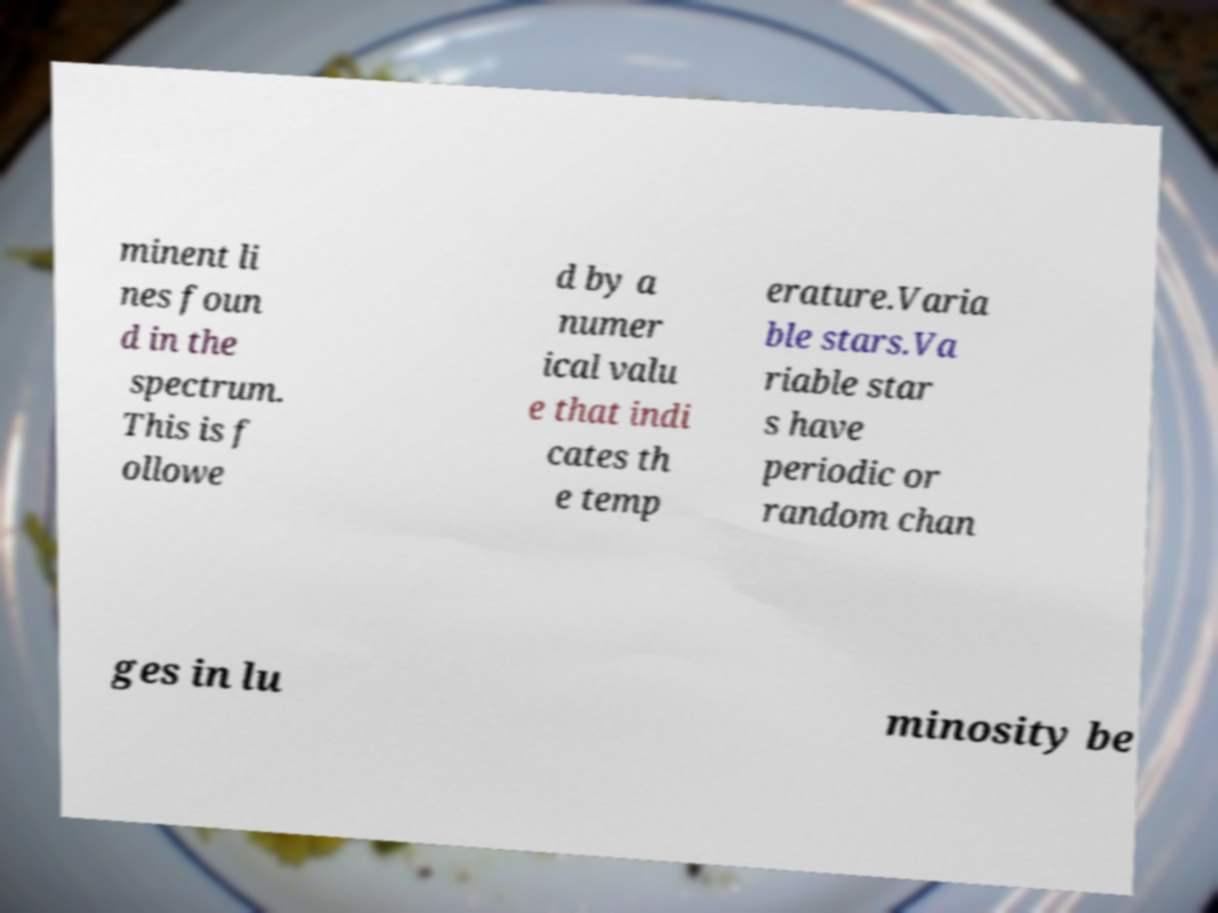There's text embedded in this image that I need extracted. Can you transcribe it verbatim? minent li nes foun d in the spectrum. This is f ollowe d by a numer ical valu e that indi cates th e temp erature.Varia ble stars.Va riable star s have periodic or random chan ges in lu minosity be 